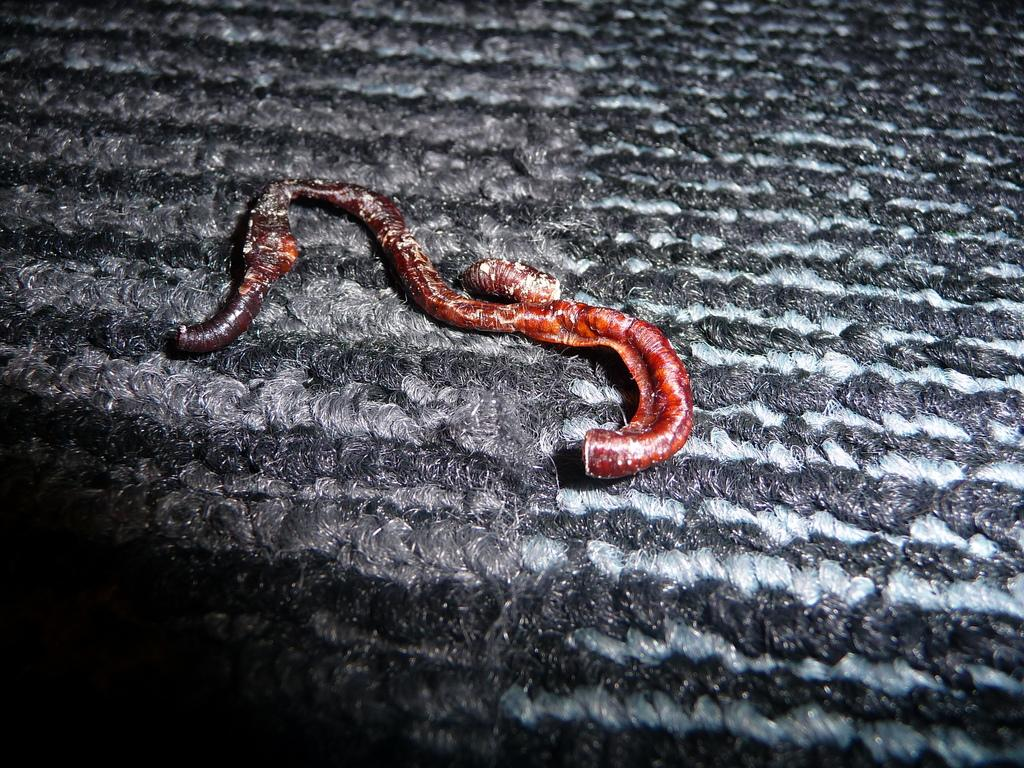What is the color of the object in the image? The object in the image is red. What type of surface is the object placed on? The object is on a woolen surface. Can you see any pain in the image? There is no pain present in the image; it is a visual representation of a red object on a woolen surface. 